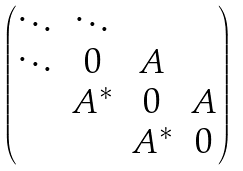Convert formula to latex. <formula><loc_0><loc_0><loc_500><loc_500>\begin{pmatrix} \ddots & \ddots & & \\ \ddots & 0 & A & \\ & A ^ { * } & 0 & A \\ & & A ^ { * } & 0 \\ \end{pmatrix}</formula> 